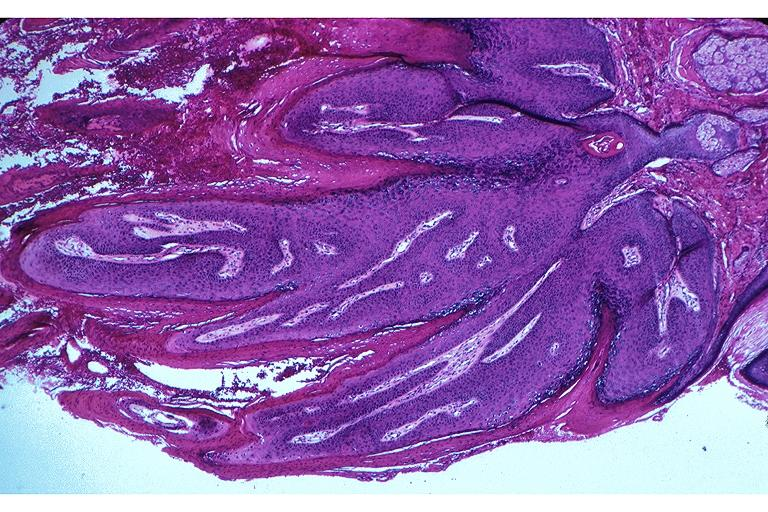what does this image show?
Answer the question using a single word or phrase. Papilloma 